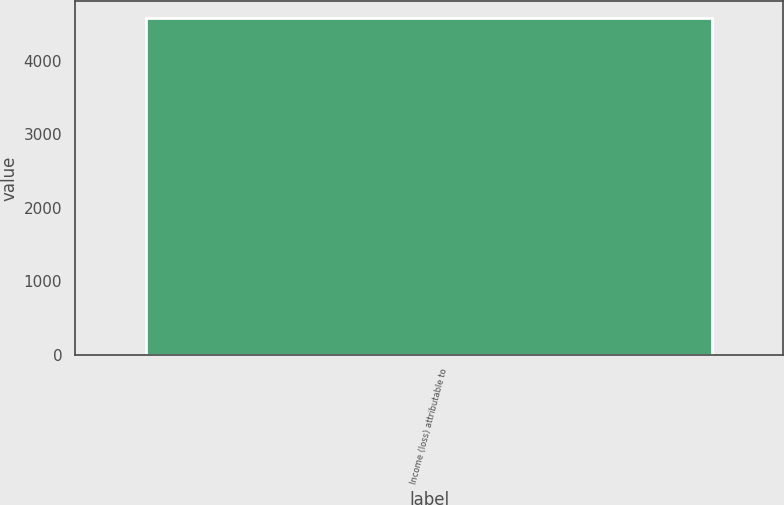<chart> <loc_0><loc_0><loc_500><loc_500><bar_chart><fcel>Income (loss) attributable to<nl><fcel>4584<nl></chart> 